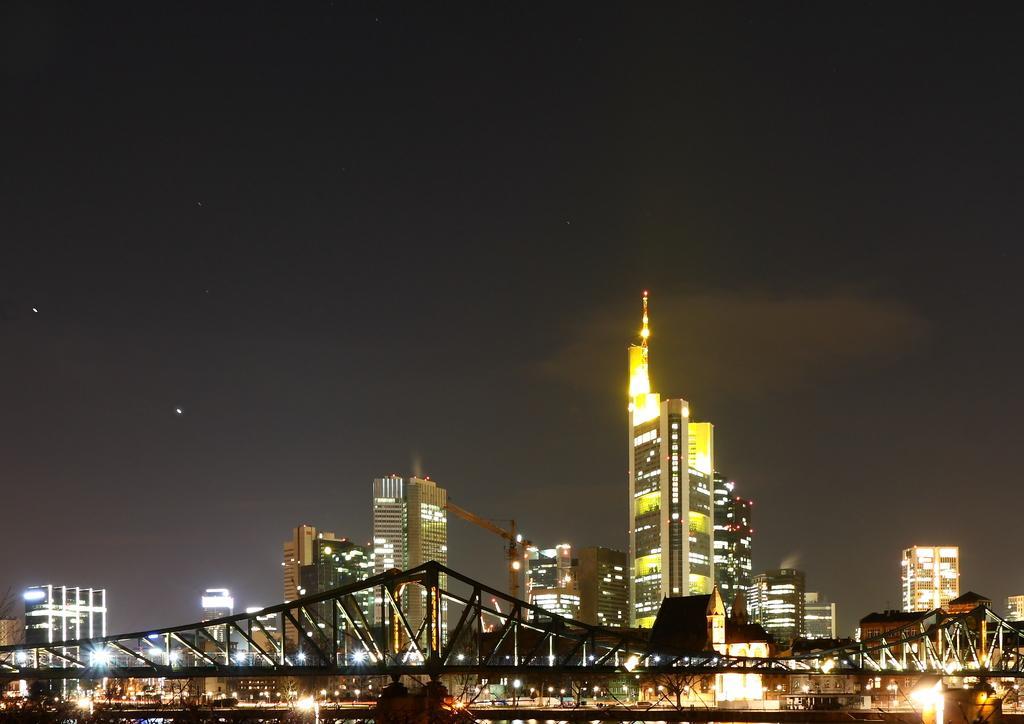Can you describe this image briefly? In the image we can see there are many buildings. This is a bridge, fence, lights, tower and a sky. 